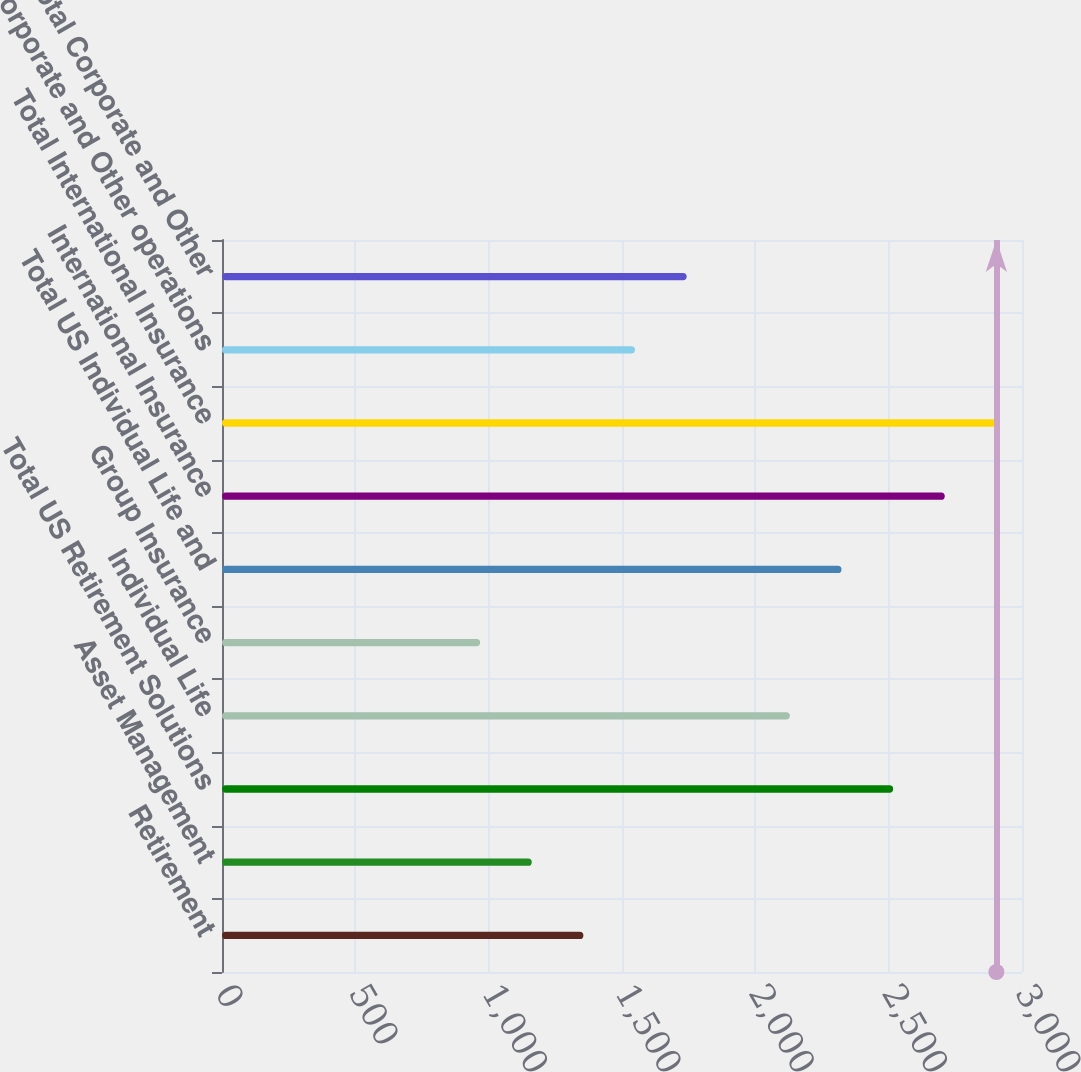<chart> <loc_0><loc_0><loc_500><loc_500><bar_chart><fcel>Retirement<fcel>Asset Management<fcel>Total US Retirement Solutions<fcel>Individual Life<fcel>Group Insurance<fcel>Total US Individual Life and<fcel>International Insurance<fcel>Total International Insurance<fcel>Corporate and Other operations<fcel>Total Corporate and Other<nl><fcel>1355.24<fcel>1161.65<fcel>2516.78<fcel>2129.6<fcel>968.06<fcel>2323.19<fcel>2710.37<fcel>2903.96<fcel>1548.83<fcel>1742.42<nl></chart> 